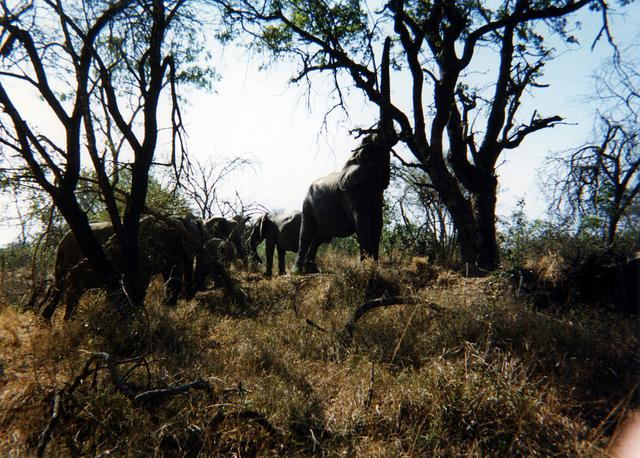In what setting are the animals?

Choices:
A) park
B) wilderness
C) zoo
D) farm wilderness 